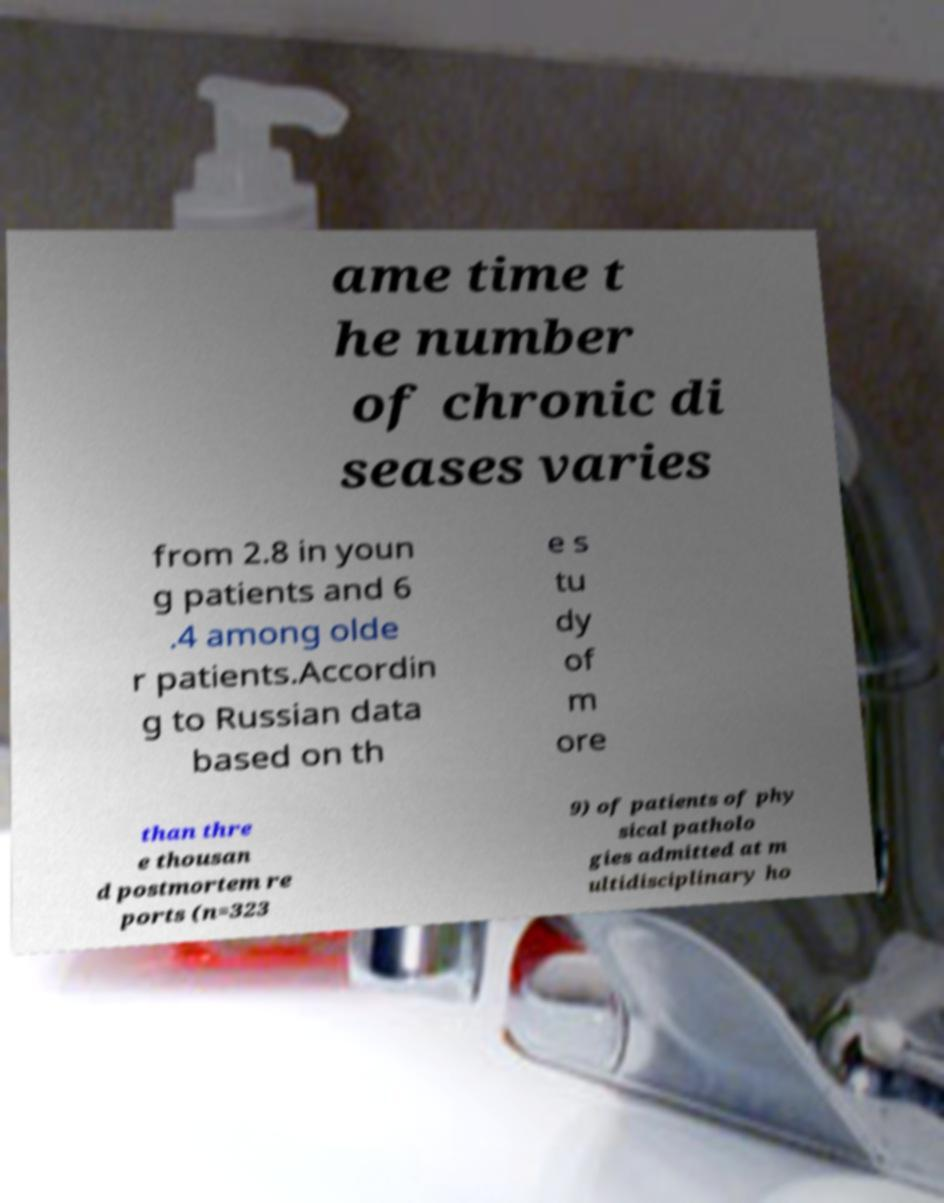Please identify and transcribe the text found in this image. ame time t he number of chronic di seases varies from 2.8 in youn g patients and 6 .4 among olde r patients.Accordin g to Russian data based on th e s tu dy of m ore than thre e thousan d postmortem re ports (n=323 9) of patients of phy sical patholo gies admitted at m ultidisciplinary ho 